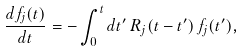<formula> <loc_0><loc_0><loc_500><loc_500>\frac { d f _ { j } ( t ) } { d t } = - \int _ { 0 } ^ { t } d t ^ { \prime } \, R _ { j } ( t - t ^ { \prime } ) \, f _ { j } ( t ^ { \prime } ) ,</formula> 